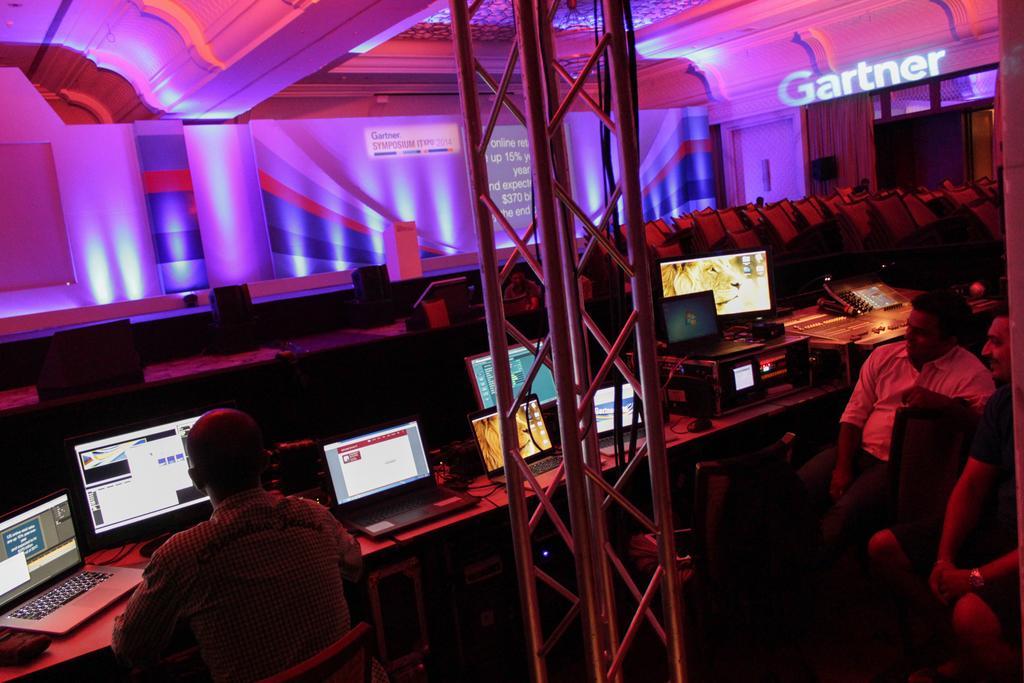Can you describe this image briefly? In this image I can see few people sitting on the chairs. In-front of these people I can see the systems on the table. There is an iron rod in-front of the people. In the back I can see the wall and to the right there is a name gardner is written. 